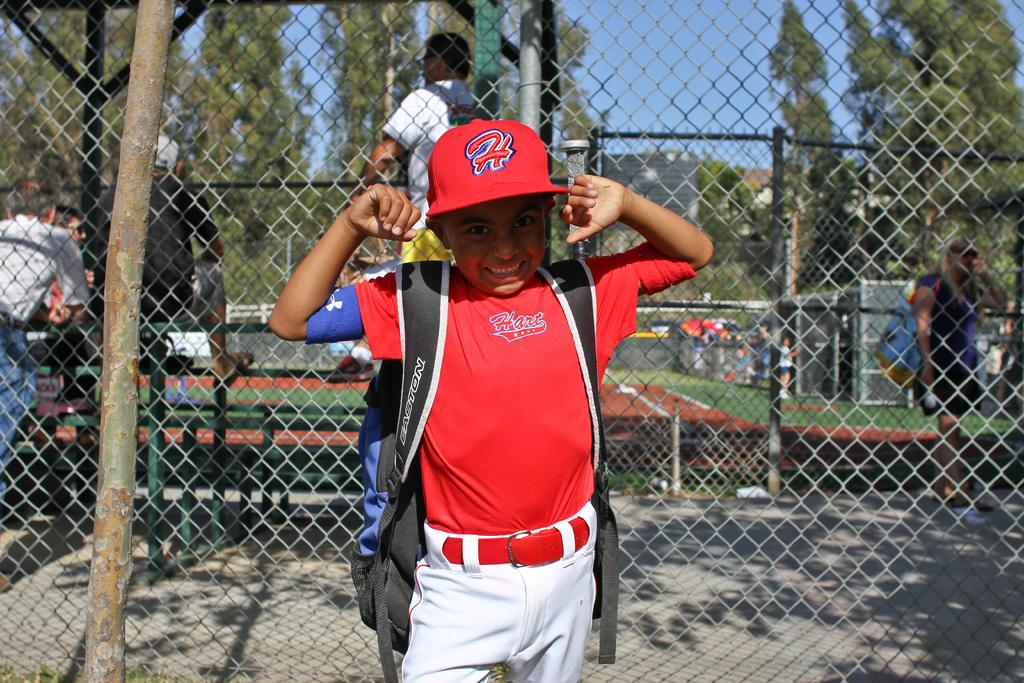<image>
Summarize the visual content of the image. A young boy is wearing a red baseball jersey and a red hat with the letter H on it. 